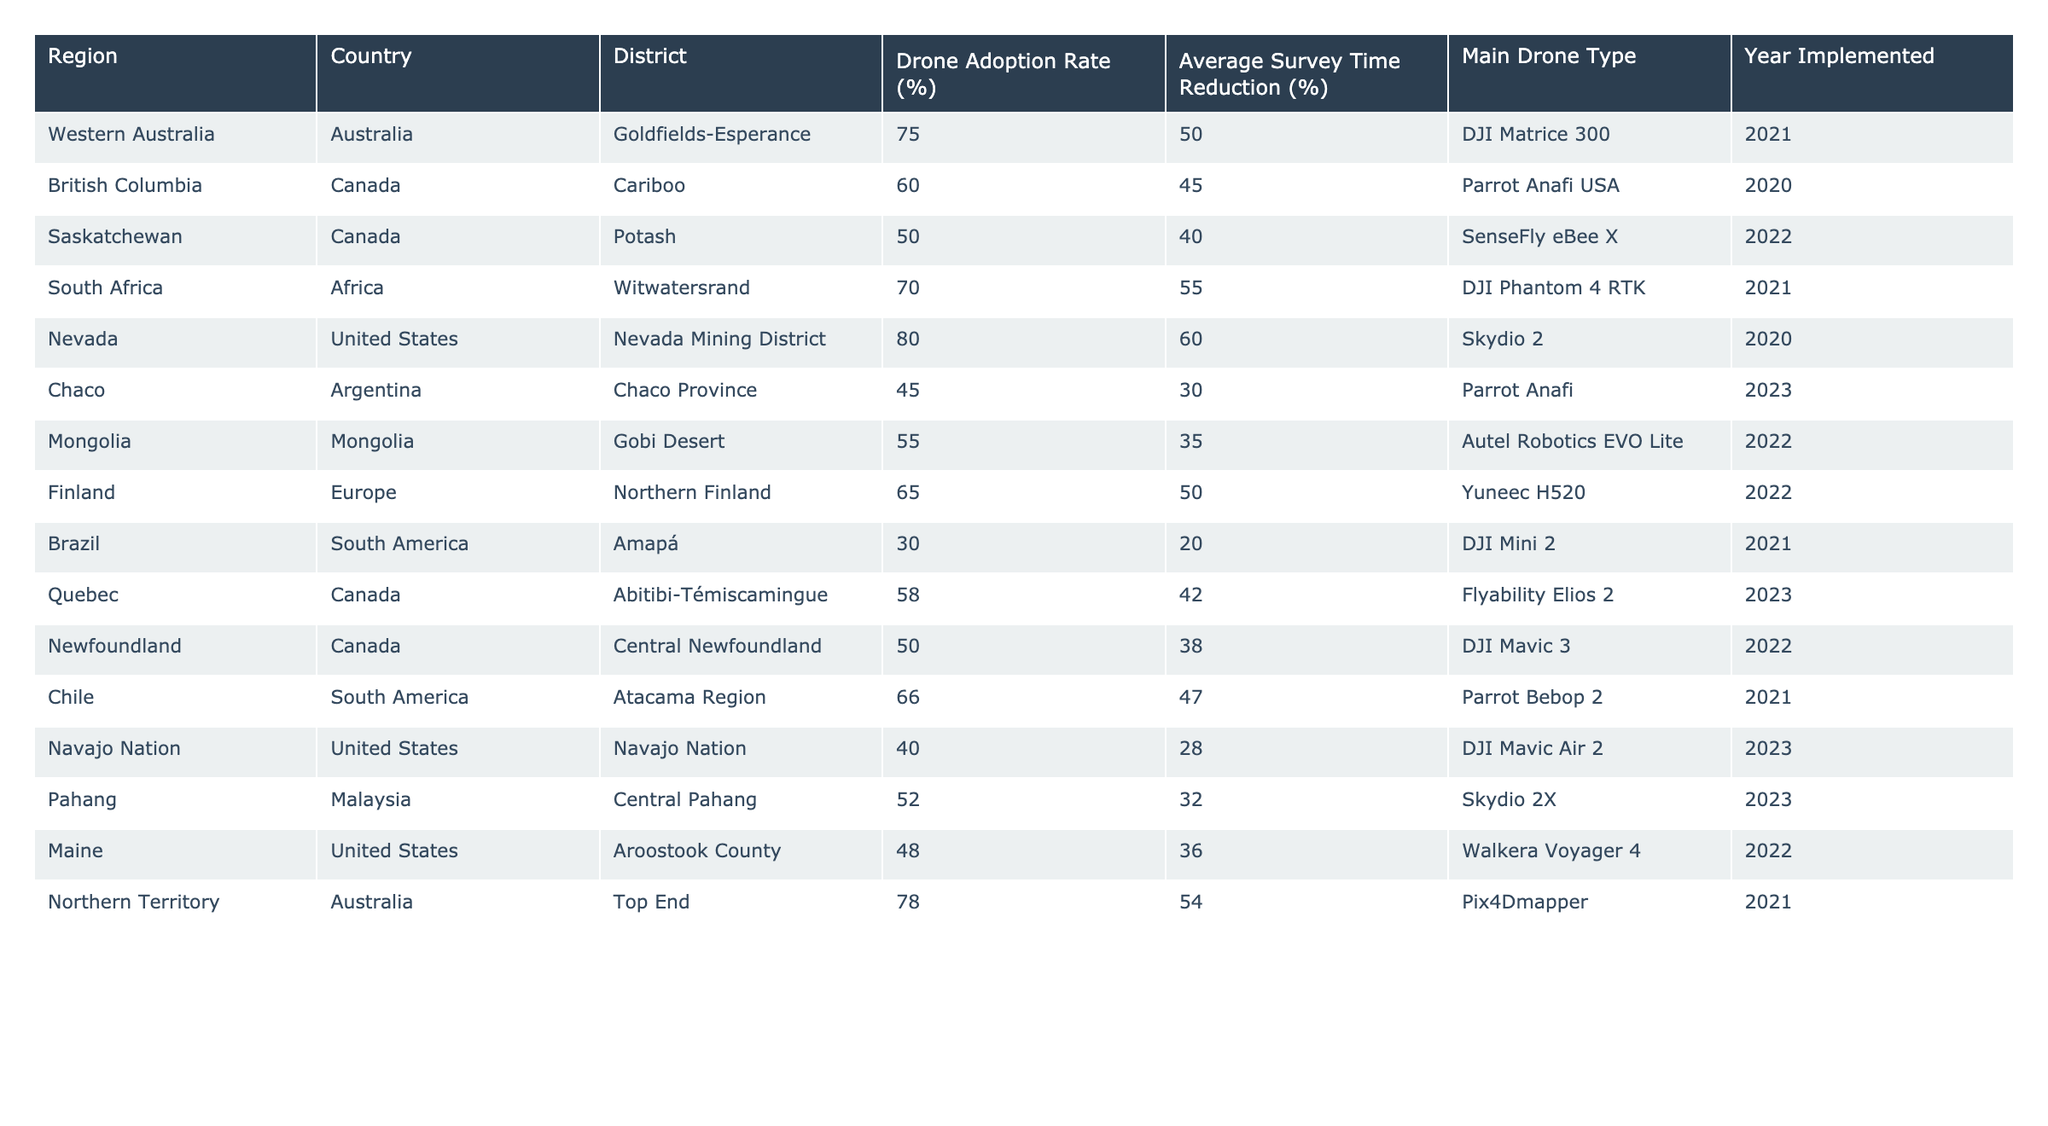What is the drone adoption rate in Northern Territory, Australia? The table lists the drone adoption rate for Northern Territory, Australia as 78%.
Answer: 78% Which drone type is most commonly used in the Nevada Mining District? The table indicates that the drone type used in the Nevada Mining District is Skydio 2.
Answer: Skydio 2 What is the average survey time reduction for regions with drone adoption rates below 50%? The regions with adoption rates below 50% are Chaco (30%), and Navajo Nation (28%). Their average survey time reductions are 30% and 28% respectively. The average is (30 + 28) / 2 = 29%.
Answer: 29% Is the drone adoption rate in South Africa higher than in British Columbia? South Africa has a drone adoption rate of 70%, while British Columbia has a rate of 60%. Since 70% is greater than 60%, the statement is true.
Answer: Yes How much greater is the average survey time reduction in regions with drone adoption rates above 60% compared to those below? Regions above 60% are Northern Territory (54%), Nevada (60%), South Africa (55%), and Western Australia (50%). Their average survey time reduction is (54 + 60 + 55 + 50) / 4 = 54.75%. Regions below 60% are Chaco (30%), Nubia Nation (28%), and Saskatchewan (40%). Their average is (30 + 28 + 40) / 3 = 32.67%. The difference is 54.75 - 32.67 ≈ 22.08%.
Answer: Approximately 22.08% Which region has the lowest drone adoption rate? The region with the lowest drone adoption rate in the table is Amapá, Brazil, with a rate of 30%.
Answer: 30% Compare the maximum drone adoption rate with the minimum in the table. The maximum drone adoption rate is 80% in Nevada, and the minimum is 30% in Amapá. The difference is 80 - 30 = 50%.
Answer: 50% What percentage of regions have a drone adoption rate of 60% or above? The regions with drone adoption rates of 60% or above are Western Australia, South Africa, Nevada, Northern Territory, and Chile. That's 5 regions out of a total of 14, so (5/14) * 100 ≈ 35.71%.
Answer: Approximately 35.71% Do all regions that implemented drone technology in 2021 have a survey time reduction above 50%? In 2021, the regions that implemented drone technology are Western Australia (50%), South Africa (55%), Northern Territory (54%). All have a survey time reduction above 50% except for Western Australia which exactly equals (50%).
Answer: No 